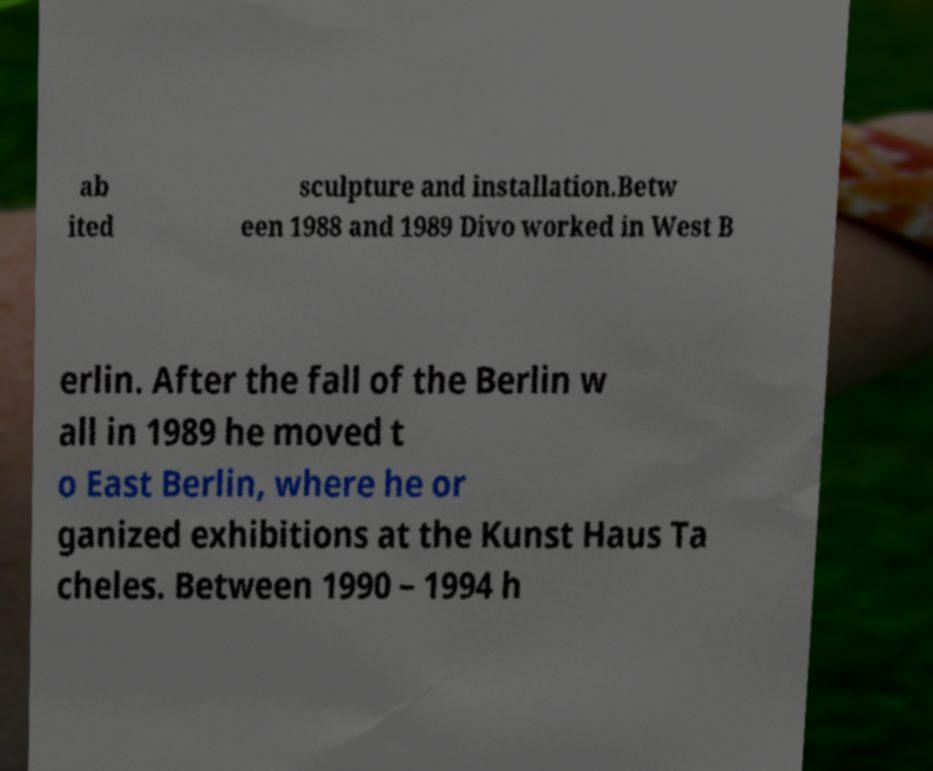There's text embedded in this image that I need extracted. Can you transcribe it verbatim? ab ited sculpture and installation.Betw een 1988 and 1989 Divo worked in West B erlin. After the fall of the Berlin w all in 1989 he moved t o East Berlin, where he or ganized exhibitions at the Kunst Haus Ta cheles. Between 1990 – 1994 h 